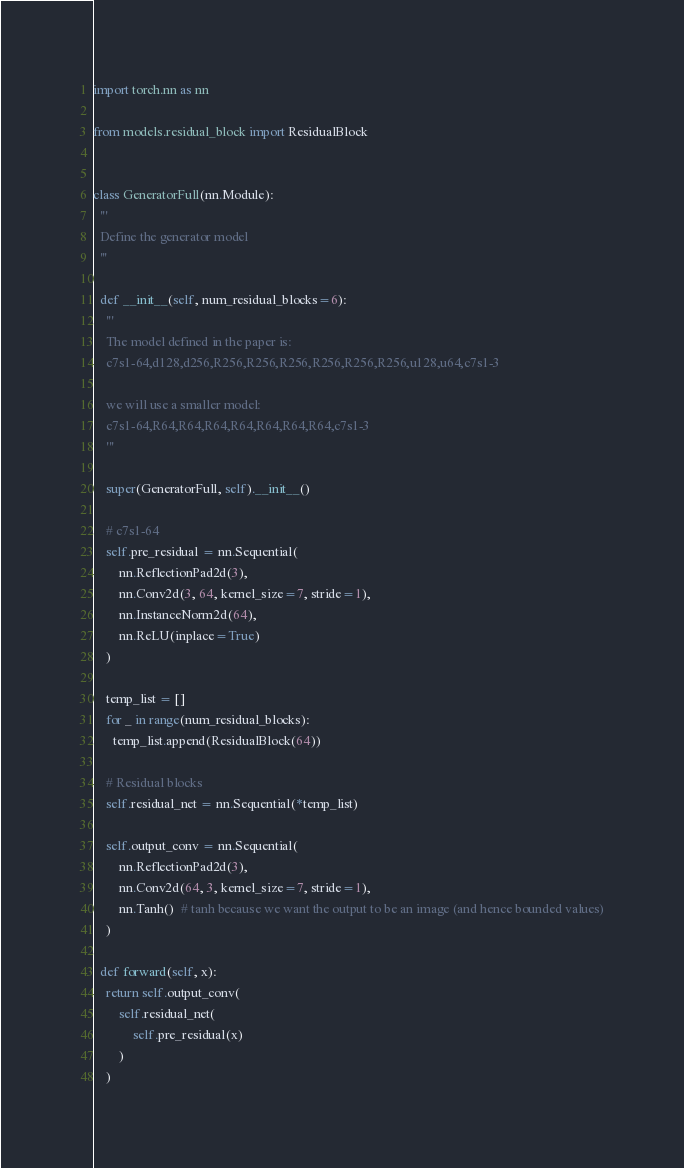Convert code to text. <code><loc_0><loc_0><loc_500><loc_500><_Python_>import torch.nn as nn

from models.residual_block import ResidualBlock


class GeneratorFull(nn.Module):
  '''
  Define the generator model
  '''

  def __init__(self, num_residual_blocks=6):
    '''
    The model defined in the paper is:
    c7s1-64,d128,d256,R256,R256,R256,R256,R256,R256,u128,u64,c7s1-3

    we will use a smaller model:
    c7s1-64,R64,R64,R64,R64,R64,R64,R64,c7s1-3
    '''

    super(GeneratorFull, self).__init__()

    # c7s1-64
    self.pre_residual = nn.Sequential(
        nn.ReflectionPad2d(3),
        nn.Conv2d(3, 64, kernel_size=7, stride=1),
        nn.InstanceNorm2d(64),
        nn.ReLU(inplace=True)
    )

    temp_list = []
    for _ in range(num_residual_blocks):
      temp_list.append(ResidualBlock(64))

    # Residual blocks
    self.residual_net = nn.Sequential(*temp_list)

    self.output_conv = nn.Sequential(
        nn.ReflectionPad2d(3),
        nn.Conv2d(64, 3, kernel_size=7, stride=1),
        nn.Tanh()  # tanh because we want the output to be an image (and hence bounded values)
    )

  def forward(self, x):
    return self.output_conv(
        self.residual_net(
            self.pre_residual(x)
        )
    )
</code> 